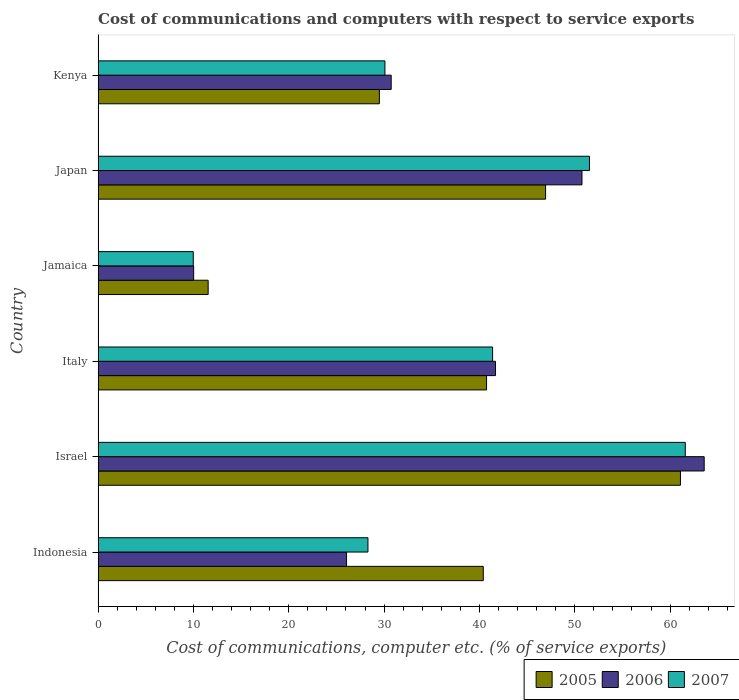How many different coloured bars are there?
Keep it short and to the point. 3. How many groups of bars are there?
Keep it short and to the point. 6. Are the number of bars per tick equal to the number of legend labels?
Give a very brief answer. Yes. What is the label of the 4th group of bars from the top?
Offer a very short reply. Italy. What is the cost of communications and computers in 2007 in Japan?
Offer a very short reply. 51.54. Across all countries, what is the maximum cost of communications and computers in 2007?
Keep it short and to the point. 61.59. Across all countries, what is the minimum cost of communications and computers in 2006?
Keep it short and to the point. 10.02. In which country was the cost of communications and computers in 2005 maximum?
Offer a terse response. Israel. In which country was the cost of communications and computers in 2005 minimum?
Your response must be concise. Jamaica. What is the total cost of communications and computers in 2006 in the graph?
Provide a succinct answer. 222.84. What is the difference between the cost of communications and computers in 2007 in Israel and that in Kenya?
Keep it short and to the point. 31.51. What is the difference between the cost of communications and computers in 2005 in Japan and the cost of communications and computers in 2007 in Jamaica?
Offer a very short reply. 36.96. What is the average cost of communications and computers in 2005 per country?
Provide a succinct answer. 38.37. What is the difference between the cost of communications and computers in 2005 and cost of communications and computers in 2007 in Israel?
Offer a very short reply. -0.51. What is the ratio of the cost of communications and computers in 2005 in Israel to that in Japan?
Offer a very short reply. 1.3. Is the difference between the cost of communications and computers in 2005 in Israel and Jamaica greater than the difference between the cost of communications and computers in 2007 in Israel and Jamaica?
Provide a succinct answer. No. What is the difference between the highest and the second highest cost of communications and computers in 2005?
Your answer should be compact. 14.15. What is the difference between the highest and the lowest cost of communications and computers in 2005?
Your response must be concise. 49.54. In how many countries, is the cost of communications and computers in 2005 greater than the average cost of communications and computers in 2005 taken over all countries?
Ensure brevity in your answer.  4. Is it the case that in every country, the sum of the cost of communications and computers in 2006 and cost of communications and computers in 2005 is greater than the cost of communications and computers in 2007?
Your answer should be very brief. Yes. How many bars are there?
Provide a short and direct response. 18. What is the difference between two consecutive major ticks on the X-axis?
Your answer should be very brief. 10. Are the values on the major ticks of X-axis written in scientific E-notation?
Ensure brevity in your answer.  No. Does the graph contain grids?
Offer a very short reply. No. Where does the legend appear in the graph?
Offer a very short reply. Bottom right. How are the legend labels stacked?
Give a very brief answer. Horizontal. What is the title of the graph?
Ensure brevity in your answer.  Cost of communications and computers with respect to service exports. Does "1994" appear as one of the legend labels in the graph?
Ensure brevity in your answer.  No. What is the label or title of the X-axis?
Give a very brief answer. Cost of communications, computer etc. (% of service exports). What is the Cost of communications, computer etc. (% of service exports) in 2005 in Indonesia?
Your answer should be compact. 40.4. What is the Cost of communications, computer etc. (% of service exports) in 2006 in Indonesia?
Give a very brief answer. 26.06. What is the Cost of communications, computer etc. (% of service exports) in 2007 in Indonesia?
Your response must be concise. 28.31. What is the Cost of communications, computer etc. (% of service exports) of 2005 in Israel?
Your response must be concise. 61.09. What is the Cost of communications, computer etc. (% of service exports) of 2006 in Israel?
Offer a very short reply. 63.58. What is the Cost of communications, computer etc. (% of service exports) in 2007 in Israel?
Offer a very short reply. 61.59. What is the Cost of communications, computer etc. (% of service exports) of 2005 in Italy?
Provide a succinct answer. 40.75. What is the Cost of communications, computer etc. (% of service exports) in 2006 in Italy?
Give a very brief answer. 41.69. What is the Cost of communications, computer etc. (% of service exports) of 2007 in Italy?
Provide a short and direct response. 41.38. What is the Cost of communications, computer etc. (% of service exports) in 2005 in Jamaica?
Make the answer very short. 11.54. What is the Cost of communications, computer etc. (% of service exports) of 2006 in Jamaica?
Keep it short and to the point. 10.02. What is the Cost of communications, computer etc. (% of service exports) of 2007 in Jamaica?
Give a very brief answer. 9.98. What is the Cost of communications, computer etc. (% of service exports) of 2005 in Japan?
Keep it short and to the point. 46.94. What is the Cost of communications, computer etc. (% of service exports) in 2006 in Japan?
Provide a short and direct response. 50.76. What is the Cost of communications, computer etc. (% of service exports) in 2007 in Japan?
Keep it short and to the point. 51.54. What is the Cost of communications, computer etc. (% of service exports) of 2005 in Kenya?
Your answer should be compact. 29.5. What is the Cost of communications, computer etc. (% of service exports) of 2006 in Kenya?
Your answer should be very brief. 30.74. What is the Cost of communications, computer etc. (% of service exports) in 2007 in Kenya?
Provide a succinct answer. 30.09. Across all countries, what is the maximum Cost of communications, computer etc. (% of service exports) in 2005?
Give a very brief answer. 61.09. Across all countries, what is the maximum Cost of communications, computer etc. (% of service exports) in 2006?
Your answer should be very brief. 63.58. Across all countries, what is the maximum Cost of communications, computer etc. (% of service exports) of 2007?
Provide a short and direct response. 61.59. Across all countries, what is the minimum Cost of communications, computer etc. (% of service exports) in 2005?
Keep it short and to the point. 11.54. Across all countries, what is the minimum Cost of communications, computer etc. (% of service exports) in 2006?
Offer a terse response. 10.02. Across all countries, what is the minimum Cost of communications, computer etc. (% of service exports) in 2007?
Your response must be concise. 9.98. What is the total Cost of communications, computer etc. (% of service exports) in 2005 in the graph?
Give a very brief answer. 230.23. What is the total Cost of communications, computer etc. (% of service exports) of 2006 in the graph?
Ensure brevity in your answer.  222.84. What is the total Cost of communications, computer etc. (% of service exports) in 2007 in the graph?
Keep it short and to the point. 222.89. What is the difference between the Cost of communications, computer etc. (% of service exports) in 2005 in Indonesia and that in Israel?
Ensure brevity in your answer.  -20.68. What is the difference between the Cost of communications, computer etc. (% of service exports) of 2006 in Indonesia and that in Israel?
Offer a terse response. -37.52. What is the difference between the Cost of communications, computer etc. (% of service exports) of 2007 in Indonesia and that in Israel?
Your response must be concise. -33.29. What is the difference between the Cost of communications, computer etc. (% of service exports) of 2005 in Indonesia and that in Italy?
Make the answer very short. -0.34. What is the difference between the Cost of communications, computer etc. (% of service exports) of 2006 in Indonesia and that in Italy?
Your answer should be very brief. -15.63. What is the difference between the Cost of communications, computer etc. (% of service exports) of 2007 in Indonesia and that in Italy?
Offer a very short reply. -13.07. What is the difference between the Cost of communications, computer etc. (% of service exports) of 2005 in Indonesia and that in Jamaica?
Give a very brief answer. 28.86. What is the difference between the Cost of communications, computer etc. (% of service exports) in 2006 in Indonesia and that in Jamaica?
Your answer should be very brief. 16.04. What is the difference between the Cost of communications, computer etc. (% of service exports) of 2007 in Indonesia and that in Jamaica?
Your response must be concise. 18.32. What is the difference between the Cost of communications, computer etc. (% of service exports) of 2005 in Indonesia and that in Japan?
Keep it short and to the point. -6.54. What is the difference between the Cost of communications, computer etc. (% of service exports) in 2006 in Indonesia and that in Japan?
Your answer should be compact. -24.7. What is the difference between the Cost of communications, computer etc. (% of service exports) in 2007 in Indonesia and that in Japan?
Provide a short and direct response. -23.24. What is the difference between the Cost of communications, computer etc. (% of service exports) in 2005 in Indonesia and that in Kenya?
Your answer should be compact. 10.9. What is the difference between the Cost of communications, computer etc. (% of service exports) in 2006 in Indonesia and that in Kenya?
Provide a short and direct response. -4.68. What is the difference between the Cost of communications, computer etc. (% of service exports) in 2007 in Indonesia and that in Kenya?
Keep it short and to the point. -1.78. What is the difference between the Cost of communications, computer etc. (% of service exports) in 2005 in Israel and that in Italy?
Your response must be concise. 20.34. What is the difference between the Cost of communications, computer etc. (% of service exports) in 2006 in Israel and that in Italy?
Your answer should be compact. 21.89. What is the difference between the Cost of communications, computer etc. (% of service exports) in 2007 in Israel and that in Italy?
Make the answer very short. 20.21. What is the difference between the Cost of communications, computer etc. (% of service exports) of 2005 in Israel and that in Jamaica?
Your answer should be very brief. 49.54. What is the difference between the Cost of communications, computer etc. (% of service exports) of 2006 in Israel and that in Jamaica?
Keep it short and to the point. 53.55. What is the difference between the Cost of communications, computer etc. (% of service exports) in 2007 in Israel and that in Jamaica?
Give a very brief answer. 51.61. What is the difference between the Cost of communications, computer etc. (% of service exports) in 2005 in Israel and that in Japan?
Make the answer very short. 14.15. What is the difference between the Cost of communications, computer etc. (% of service exports) of 2006 in Israel and that in Japan?
Offer a very short reply. 12.82. What is the difference between the Cost of communications, computer etc. (% of service exports) of 2007 in Israel and that in Japan?
Keep it short and to the point. 10.05. What is the difference between the Cost of communications, computer etc. (% of service exports) of 2005 in Israel and that in Kenya?
Provide a short and direct response. 31.58. What is the difference between the Cost of communications, computer etc. (% of service exports) of 2006 in Israel and that in Kenya?
Ensure brevity in your answer.  32.83. What is the difference between the Cost of communications, computer etc. (% of service exports) in 2007 in Israel and that in Kenya?
Offer a terse response. 31.51. What is the difference between the Cost of communications, computer etc. (% of service exports) of 2005 in Italy and that in Jamaica?
Keep it short and to the point. 29.2. What is the difference between the Cost of communications, computer etc. (% of service exports) in 2006 in Italy and that in Jamaica?
Provide a short and direct response. 31.66. What is the difference between the Cost of communications, computer etc. (% of service exports) of 2007 in Italy and that in Jamaica?
Offer a very short reply. 31.4. What is the difference between the Cost of communications, computer etc. (% of service exports) in 2005 in Italy and that in Japan?
Keep it short and to the point. -6.19. What is the difference between the Cost of communications, computer etc. (% of service exports) in 2006 in Italy and that in Japan?
Keep it short and to the point. -9.07. What is the difference between the Cost of communications, computer etc. (% of service exports) in 2007 in Italy and that in Japan?
Ensure brevity in your answer.  -10.16. What is the difference between the Cost of communications, computer etc. (% of service exports) of 2005 in Italy and that in Kenya?
Offer a very short reply. 11.24. What is the difference between the Cost of communications, computer etc. (% of service exports) of 2006 in Italy and that in Kenya?
Give a very brief answer. 10.94. What is the difference between the Cost of communications, computer etc. (% of service exports) in 2007 in Italy and that in Kenya?
Your answer should be compact. 11.29. What is the difference between the Cost of communications, computer etc. (% of service exports) in 2005 in Jamaica and that in Japan?
Your answer should be compact. -35.4. What is the difference between the Cost of communications, computer etc. (% of service exports) of 2006 in Jamaica and that in Japan?
Offer a very short reply. -40.74. What is the difference between the Cost of communications, computer etc. (% of service exports) of 2007 in Jamaica and that in Japan?
Ensure brevity in your answer.  -41.56. What is the difference between the Cost of communications, computer etc. (% of service exports) in 2005 in Jamaica and that in Kenya?
Provide a short and direct response. -17.96. What is the difference between the Cost of communications, computer etc. (% of service exports) in 2006 in Jamaica and that in Kenya?
Offer a very short reply. -20.72. What is the difference between the Cost of communications, computer etc. (% of service exports) in 2007 in Jamaica and that in Kenya?
Give a very brief answer. -20.1. What is the difference between the Cost of communications, computer etc. (% of service exports) of 2005 in Japan and that in Kenya?
Provide a succinct answer. 17.44. What is the difference between the Cost of communications, computer etc. (% of service exports) of 2006 in Japan and that in Kenya?
Provide a succinct answer. 20.01. What is the difference between the Cost of communications, computer etc. (% of service exports) of 2007 in Japan and that in Kenya?
Keep it short and to the point. 21.46. What is the difference between the Cost of communications, computer etc. (% of service exports) of 2005 in Indonesia and the Cost of communications, computer etc. (% of service exports) of 2006 in Israel?
Ensure brevity in your answer.  -23.17. What is the difference between the Cost of communications, computer etc. (% of service exports) of 2005 in Indonesia and the Cost of communications, computer etc. (% of service exports) of 2007 in Israel?
Keep it short and to the point. -21.19. What is the difference between the Cost of communications, computer etc. (% of service exports) in 2006 in Indonesia and the Cost of communications, computer etc. (% of service exports) in 2007 in Israel?
Provide a succinct answer. -35.53. What is the difference between the Cost of communications, computer etc. (% of service exports) of 2005 in Indonesia and the Cost of communications, computer etc. (% of service exports) of 2006 in Italy?
Give a very brief answer. -1.28. What is the difference between the Cost of communications, computer etc. (% of service exports) of 2005 in Indonesia and the Cost of communications, computer etc. (% of service exports) of 2007 in Italy?
Offer a very short reply. -0.98. What is the difference between the Cost of communications, computer etc. (% of service exports) in 2006 in Indonesia and the Cost of communications, computer etc. (% of service exports) in 2007 in Italy?
Make the answer very short. -15.32. What is the difference between the Cost of communications, computer etc. (% of service exports) of 2005 in Indonesia and the Cost of communications, computer etc. (% of service exports) of 2006 in Jamaica?
Provide a succinct answer. 30.38. What is the difference between the Cost of communications, computer etc. (% of service exports) in 2005 in Indonesia and the Cost of communications, computer etc. (% of service exports) in 2007 in Jamaica?
Your answer should be very brief. 30.42. What is the difference between the Cost of communications, computer etc. (% of service exports) in 2006 in Indonesia and the Cost of communications, computer etc. (% of service exports) in 2007 in Jamaica?
Keep it short and to the point. 16.08. What is the difference between the Cost of communications, computer etc. (% of service exports) of 2005 in Indonesia and the Cost of communications, computer etc. (% of service exports) of 2006 in Japan?
Offer a very short reply. -10.35. What is the difference between the Cost of communications, computer etc. (% of service exports) of 2005 in Indonesia and the Cost of communications, computer etc. (% of service exports) of 2007 in Japan?
Provide a succinct answer. -11.14. What is the difference between the Cost of communications, computer etc. (% of service exports) of 2006 in Indonesia and the Cost of communications, computer etc. (% of service exports) of 2007 in Japan?
Your response must be concise. -25.48. What is the difference between the Cost of communications, computer etc. (% of service exports) of 2005 in Indonesia and the Cost of communications, computer etc. (% of service exports) of 2006 in Kenya?
Your answer should be compact. 9.66. What is the difference between the Cost of communications, computer etc. (% of service exports) of 2005 in Indonesia and the Cost of communications, computer etc. (% of service exports) of 2007 in Kenya?
Offer a terse response. 10.32. What is the difference between the Cost of communications, computer etc. (% of service exports) in 2006 in Indonesia and the Cost of communications, computer etc. (% of service exports) in 2007 in Kenya?
Offer a terse response. -4.03. What is the difference between the Cost of communications, computer etc. (% of service exports) in 2005 in Israel and the Cost of communications, computer etc. (% of service exports) in 2006 in Italy?
Give a very brief answer. 19.4. What is the difference between the Cost of communications, computer etc. (% of service exports) of 2005 in Israel and the Cost of communications, computer etc. (% of service exports) of 2007 in Italy?
Your answer should be compact. 19.71. What is the difference between the Cost of communications, computer etc. (% of service exports) in 2006 in Israel and the Cost of communications, computer etc. (% of service exports) in 2007 in Italy?
Ensure brevity in your answer.  22.2. What is the difference between the Cost of communications, computer etc. (% of service exports) of 2005 in Israel and the Cost of communications, computer etc. (% of service exports) of 2006 in Jamaica?
Make the answer very short. 51.07. What is the difference between the Cost of communications, computer etc. (% of service exports) of 2005 in Israel and the Cost of communications, computer etc. (% of service exports) of 2007 in Jamaica?
Make the answer very short. 51.11. What is the difference between the Cost of communications, computer etc. (% of service exports) of 2006 in Israel and the Cost of communications, computer etc. (% of service exports) of 2007 in Jamaica?
Provide a succinct answer. 53.59. What is the difference between the Cost of communications, computer etc. (% of service exports) in 2005 in Israel and the Cost of communications, computer etc. (% of service exports) in 2006 in Japan?
Offer a very short reply. 10.33. What is the difference between the Cost of communications, computer etc. (% of service exports) of 2005 in Israel and the Cost of communications, computer etc. (% of service exports) of 2007 in Japan?
Your answer should be compact. 9.55. What is the difference between the Cost of communications, computer etc. (% of service exports) in 2006 in Israel and the Cost of communications, computer etc. (% of service exports) in 2007 in Japan?
Provide a short and direct response. 12.03. What is the difference between the Cost of communications, computer etc. (% of service exports) in 2005 in Israel and the Cost of communications, computer etc. (% of service exports) in 2006 in Kenya?
Give a very brief answer. 30.34. What is the difference between the Cost of communications, computer etc. (% of service exports) in 2005 in Israel and the Cost of communications, computer etc. (% of service exports) in 2007 in Kenya?
Offer a very short reply. 31. What is the difference between the Cost of communications, computer etc. (% of service exports) in 2006 in Israel and the Cost of communications, computer etc. (% of service exports) in 2007 in Kenya?
Offer a terse response. 33.49. What is the difference between the Cost of communications, computer etc. (% of service exports) of 2005 in Italy and the Cost of communications, computer etc. (% of service exports) of 2006 in Jamaica?
Give a very brief answer. 30.73. What is the difference between the Cost of communications, computer etc. (% of service exports) in 2005 in Italy and the Cost of communications, computer etc. (% of service exports) in 2007 in Jamaica?
Keep it short and to the point. 30.77. What is the difference between the Cost of communications, computer etc. (% of service exports) in 2006 in Italy and the Cost of communications, computer etc. (% of service exports) in 2007 in Jamaica?
Give a very brief answer. 31.7. What is the difference between the Cost of communications, computer etc. (% of service exports) of 2005 in Italy and the Cost of communications, computer etc. (% of service exports) of 2006 in Japan?
Your response must be concise. -10.01. What is the difference between the Cost of communications, computer etc. (% of service exports) in 2005 in Italy and the Cost of communications, computer etc. (% of service exports) in 2007 in Japan?
Offer a terse response. -10.79. What is the difference between the Cost of communications, computer etc. (% of service exports) of 2006 in Italy and the Cost of communications, computer etc. (% of service exports) of 2007 in Japan?
Give a very brief answer. -9.86. What is the difference between the Cost of communications, computer etc. (% of service exports) in 2005 in Italy and the Cost of communications, computer etc. (% of service exports) in 2006 in Kenya?
Give a very brief answer. 10. What is the difference between the Cost of communications, computer etc. (% of service exports) in 2005 in Italy and the Cost of communications, computer etc. (% of service exports) in 2007 in Kenya?
Ensure brevity in your answer.  10.66. What is the difference between the Cost of communications, computer etc. (% of service exports) of 2006 in Italy and the Cost of communications, computer etc. (% of service exports) of 2007 in Kenya?
Make the answer very short. 11.6. What is the difference between the Cost of communications, computer etc. (% of service exports) in 2005 in Jamaica and the Cost of communications, computer etc. (% of service exports) in 2006 in Japan?
Provide a succinct answer. -39.21. What is the difference between the Cost of communications, computer etc. (% of service exports) of 2005 in Jamaica and the Cost of communications, computer etc. (% of service exports) of 2007 in Japan?
Offer a terse response. -40. What is the difference between the Cost of communications, computer etc. (% of service exports) of 2006 in Jamaica and the Cost of communications, computer etc. (% of service exports) of 2007 in Japan?
Your response must be concise. -41.52. What is the difference between the Cost of communications, computer etc. (% of service exports) in 2005 in Jamaica and the Cost of communications, computer etc. (% of service exports) in 2006 in Kenya?
Your response must be concise. -19.2. What is the difference between the Cost of communications, computer etc. (% of service exports) of 2005 in Jamaica and the Cost of communications, computer etc. (% of service exports) of 2007 in Kenya?
Your response must be concise. -18.54. What is the difference between the Cost of communications, computer etc. (% of service exports) of 2006 in Jamaica and the Cost of communications, computer etc. (% of service exports) of 2007 in Kenya?
Provide a short and direct response. -20.06. What is the difference between the Cost of communications, computer etc. (% of service exports) in 2005 in Japan and the Cost of communications, computer etc. (% of service exports) in 2006 in Kenya?
Provide a short and direct response. 16.2. What is the difference between the Cost of communications, computer etc. (% of service exports) in 2005 in Japan and the Cost of communications, computer etc. (% of service exports) in 2007 in Kenya?
Give a very brief answer. 16.85. What is the difference between the Cost of communications, computer etc. (% of service exports) in 2006 in Japan and the Cost of communications, computer etc. (% of service exports) in 2007 in Kenya?
Provide a succinct answer. 20.67. What is the average Cost of communications, computer etc. (% of service exports) of 2005 per country?
Offer a terse response. 38.37. What is the average Cost of communications, computer etc. (% of service exports) in 2006 per country?
Keep it short and to the point. 37.14. What is the average Cost of communications, computer etc. (% of service exports) of 2007 per country?
Your answer should be very brief. 37.15. What is the difference between the Cost of communications, computer etc. (% of service exports) in 2005 and Cost of communications, computer etc. (% of service exports) in 2006 in Indonesia?
Keep it short and to the point. 14.34. What is the difference between the Cost of communications, computer etc. (% of service exports) in 2005 and Cost of communications, computer etc. (% of service exports) in 2007 in Indonesia?
Give a very brief answer. 12.1. What is the difference between the Cost of communications, computer etc. (% of service exports) of 2006 and Cost of communications, computer etc. (% of service exports) of 2007 in Indonesia?
Give a very brief answer. -2.25. What is the difference between the Cost of communications, computer etc. (% of service exports) in 2005 and Cost of communications, computer etc. (% of service exports) in 2006 in Israel?
Provide a short and direct response. -2.49. What is the difference between the Cost of communications, computer etc. (% of service exports) of 2005 and Cost of communications, computer etc. (% of service exports) of 2007 in Israel?
Ensure brevity in your answer.  -0.51. What is the difference between the Cost of communications, computer etc. (% of service exports) in 2006 and Cost of communications, computer etc. (% of service exports) in 2007 in Israel?
Your answer should be very brief. 1.98. What is the difference between the Cost of communications, computer etc. (% of service exports) in 2005 and Cost of communications, computer etc. (% of service exports) in 2006 in Italy?
Give a very brief answer. -0.94. What is the difference between the Cost of communications, computer etc. (% of service exports) in 2005 and Cost of communications, computer etc. (% of service exports) in 2007 in Italy?
Make the answer very short. -0.63. What is the difference between the Cost of communications, computer etc. (% of service exports) of 2006 and Cost of communications, computer etc. (% of service exports) of 2007 in Italy?
Keep it short and to the point. 0.31. What is the difference between the Cost of communications, computer etc. (% of service exports) in 2005 and Cost of communications, computer etc. (% of service exports) in 2006 in Jamaica?
Offer a terse response. 1.52. What is the difference between the Cost of communications, computer etc. (% of service exports) of 2005 and Cost of communications, computer etc. (% of service exports) of 2007 in Jamaica?
Ensure brevity in your answer.  1.56. What is the difference between the Cost of communications, computer etc. (% of service exports) of 2006 and Cost of communications, computer etc. (% of service exports) of 2007 in Jamaica?
Keep it short and to the point. 0.04. What is the difference between the Cost of communications, computer etc. (% of service exports) of 2005 and Cost of communications, computer etc. (% of service exports) of 2006 in Japan?
Make the answer very short. -3.82. What is the difference between the Cost of communications, computer etc. (% of service exports) in 2005 and Cost of communications, computer etc. (% of service exports) in 2007 in Japan?
Your answer should be compact. -4.6. What is the difference between the Cost of communications, computer etc. (% of service exports) of 2006 and Cost of communications, computer etc. (% of service exports) of 2007 in Japan?
Your answer should be very brief. -0.78. What is the difference between the Cost of communications, computer etc. (% of service exports) of 2005 and Cost of communications, computer etc. (% of service exports) of 2006 in Kenya?
Your response must be concise. -1.24. What is the difference between the Cost of communications, computer etc. (% of service exports) of 2005 and Cost of communications, computer etc. (% of service exports) of 2007 in Kenya?
Provide a short and direct response. -0.58. What is the difference between the Cost of communications, computer etc. (% of service exports) in 2006 and Cost of communications, computer etc. (% of service exports) in 2007 in Kenya?
Offer a very short reply. 0.66. What is the ratio of the Cost of communications, computer etc. (% of service exports) of 2005 in Indonesia to that in Israel?
Provide a short and direct response. 0.66. What is the ratio of the Cost of communications, computer etc. (% of service exports) in 2006 in Indonesia to that in Israel?
Offer a terse response. 0.41. What is the ratio of the Cost of communications, computer etc. (% of service exports) in 2007 in Indonesia to that in Israel?
Give a very brief answer. 0.46. What is the ratio of the Cost of communications, computer etc. (% of service exports) in 2006 in Indonesia to that in Italy?
Make the answer very short. 0.63. What is the ratio of the Cost of communications, computer etc. (% of service exports) of 2007 in Indonesia to that in Italy?
Keep it short and to the point. 0.68. What is the ratio of the Cost of communications, computer etc. (% of service exports) of 2005 in Indonesia to that in Jamaica?
Your answer should be very brief. 3.5. What is the ratio of the Cost of communications, computer etc. (% of service exports) of 2006 in Indonesia to that in Jamaica?
Ensure brevity in your answer.  2.6. What is the ratio of the Cost of communications, computer etc. (% of service exports) in 2007 in Indonesia to that in Jamaica?
Give a very brief answer. 2.84. What is the ratio of the Cost of communications, computer etc. (% of service exports) in 2005 in Indonesia to that in Japan?
Ensure brevity in your answer.  0.86. What is the ratio of the Cost of communications, computer etc. (% of service exports) of 2006 in Indonesia to that in Japan?
Offer a very short reply. 0.51. What is the ratio of the Cost of communications, computer etc. (% of service exports) of 2007 in Indonesia to that in Japan?
Your answer should be compact. 0.55. What is the ratio of the Cost of communications, computer etc. (% of service exports) in 2005 in Indonesia to that in Kenya?
Offer a very short reply. 1.37. What is the ratio of the Cost of communications, computer etc. (% of service exports) of 2006 in Indonesia to that in Kenya?
Your answer should be very brief. 0.85. What is the ratio of the Cost of communications, computer etc. (% of service exports) in 2007 in Indonesia to that in Kenya?
Provide a short and direct response. 0.94. What is the ratio of the Cost of communications, computer etc. (% of service exports) of 2005 in Israel to that in Italy?
Keep it short and to the point. 1.5. What is the ratio of the Cost of communications, computer etc. (% of service exports) in 2006 in Israel to that in Italy?
Your answer should be very brief. 1.53. What is the ratio of the Cost of communications, computer etc. (% of service exports) in 2007 in Israel to that in Italy?
Give a very brief answer. 1.49. What is the ratio of the Cost of communications, computer etc. (% of service exports) of 2005 in Israel to that in Jamaica?
Your answer should be compact. 5.29. What is the ratio of the Cost of communications, computer etc. (% of service exports) in 2006 in Israel to that in Jamaica?
Your answer should be very brief. 6.34. What is the ratio of the Cost of communications, computer etc. (% of service exports) of 2007 in Israel to that in Jamaica?
Provide a short and direct response. 6.17. What is the ratio of the Cost of communications, computer etc. (% of service exports) in 2005 in Israel to that in Japan?
Give a very brief answer. 1.3. What is the ratio of the Cost of communications, computer etc. (% of service exports) in 2006 in Israel to that in Japan?
Your answer should be very brief. 1.25. What is the ratio of the Cost of communications, computer etc. (% of service exports) of 2007 in Israel to that in Japan?
Your answer should be compact. 1.2. What is the ratio of the Cost of communications, computer etc. (% of service exports) of 2005 in Israel to that in Kenya?
Give a very brief answer. 2.07. What is the ratio of the Cost of communications, computer etc. (% of service exports) of 2006 in Israel to that in Kenya?
Your response must be concise. 2.07. What is the ratio of the Cost of communications, computer etc. (% of service exports) of 2007 in Israel to that in Kenya?
Keep it short and to the point. 2.05. What is the ratio of the Cost of communications, computer etc. (% of service exports) of 2005 in Italy to that in Jamaica?
Ensure brevity in your answer.  3.53. What is the ratio of the Cost of communications, computer etc. (% of service exports) of 2006 in Italy to that in Jamaica?
Offer a very short reply. 4.16. What is the ratio of the Cost of communications, computer etc. (% of service exports) in 2007 in Italy to that in Jamaica?
Offer a terse response. 4.15. What is the ratio of the Cost of communications, computer etc. (% of service exports) of 2005 in Italy to that in Japan?
Your response must be concise. 0.87. What is the ratio of the Cost of communications, computer etc. (% of service exports) in 2006 in Italy to that in Japan?
Make the answer very short. 0.82. What is the ratio of the Cost of communications, computer etc. (% of service exports) of 2007 in Italy to that in Japan?
Your response must be concise. 0.8. What is the ratio of the Cost of communications, computer etc. (% of service exports) in 2005 in Italy to that in Kenya?
Your response must be concise. 1.38. What is the ratio of the Cost of communications, computer etc. (% of service exports) of 2006 in Italy to that in Kenya?
Your response must be concise. 1.36. What is the ratio of the Cost of communications, computer etc. (% of service exports) in 2007 in Italy to that in Kenya?
Your answer should be compact. 1.38. What is the ratio of the Cost of communications, computer etc. (% of service exports) in 2005 in Jamaica to that in Japan?
Your answer should be very brief. 0.25. What is the ratio of the Cost of communications, computer etc. (% of service exports) in 2006 in Jamaica to that in Japan?
Your answer should be compact. 0.2. What is the ratio of the Cost of communications, computer etc. (% of service exports) in 2007 in Jamaica to that in Japan?
Ensure brevity in your answer.  0.19. What is the ratio of the Cost of communications, computer etc. (% of service exports) of 2005 in Jamaica to that in Kenya?
Provide a succinct answer. 0.39. What is the ratio of the Cost of communications, computer etc. (% of service exports) in 2006 in Jamaica to that in Kenya?
Make the answer very short. 0.33. What is the ratio of the Cost of communications, computer etc. (% of service exports) in 2007 in Jamaica to that in Kenya?
Give a very brief answer. 0.33. What is the ratio of the Cost of communications, computer etc. (% of service exports) of 2005 in Japan to that in Kenya?
Your answer should be very brief. 1.59. What is the ratio of the Cost of communications, computer etc. (% of service exports) of 2006 in Japan to that in Kenya?
Make the answer very short. 1.65. What is the ratio of the Cost of communications, computer etc. (% of service exports) in 2007 in Japan to that in Kenya?
Ensure brevity in your answer.  1.71. What is the difference between the highest and the second highest Cost of communications, computer etc. (% of service exports) of 2005?
Make the answer very short. 14.15. What is the difference between the highest and the second highest Cost of communications, computer etc. (% of service exports) of 2006?
Your response must be concise. 12.82. What is the difference between the highest and the second highest Cost of communications, computer etc. (% of service exports) in 2007?
Provide a short and direct response. 10.05. What is the difference between the highest and the lowest Cost of communications, computer etc. (% of service exports) in 2005?
Give a very brief answer. 49.54. What is the difference between the highest and the lowest Cost of communications, computer etc. (% of service exports) in 2006?
Offer a terse response. 53.55. What is the difference between the highest and the lowest Cost of communications, computer etc. (% of service exports) in 2007?
Your answer should be very brief. 51.61. 